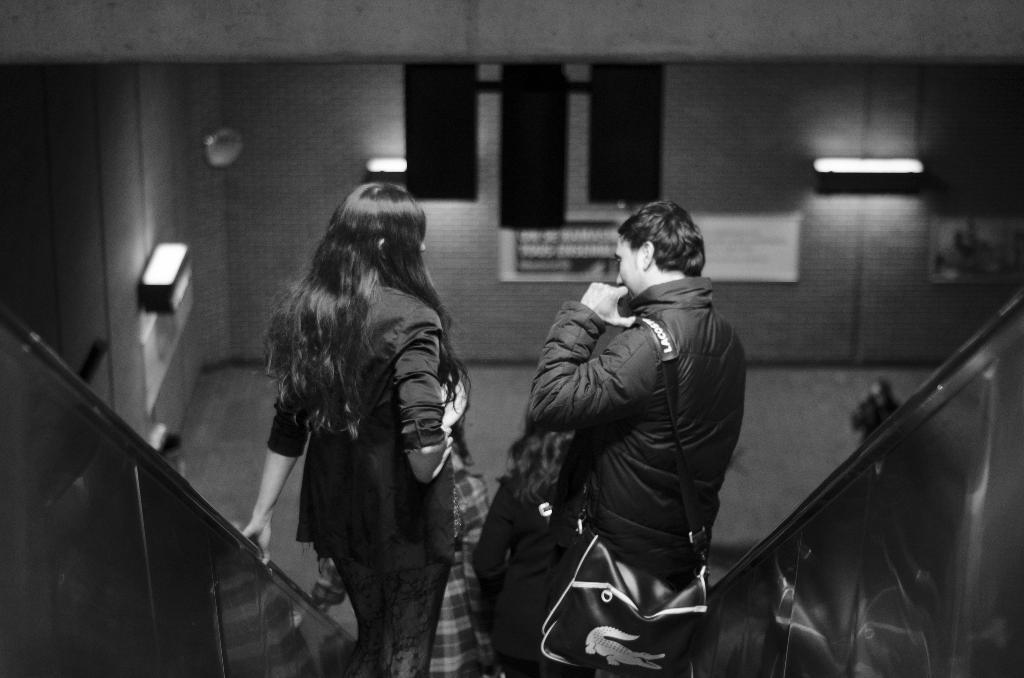How would you summarize this image in a sentence or two? This is a black and white image and here we can see people on the escalator and one of them is wearing a bag. In the background, there are lights and we can see boards on the wall. At the bottom, there is a floor. 